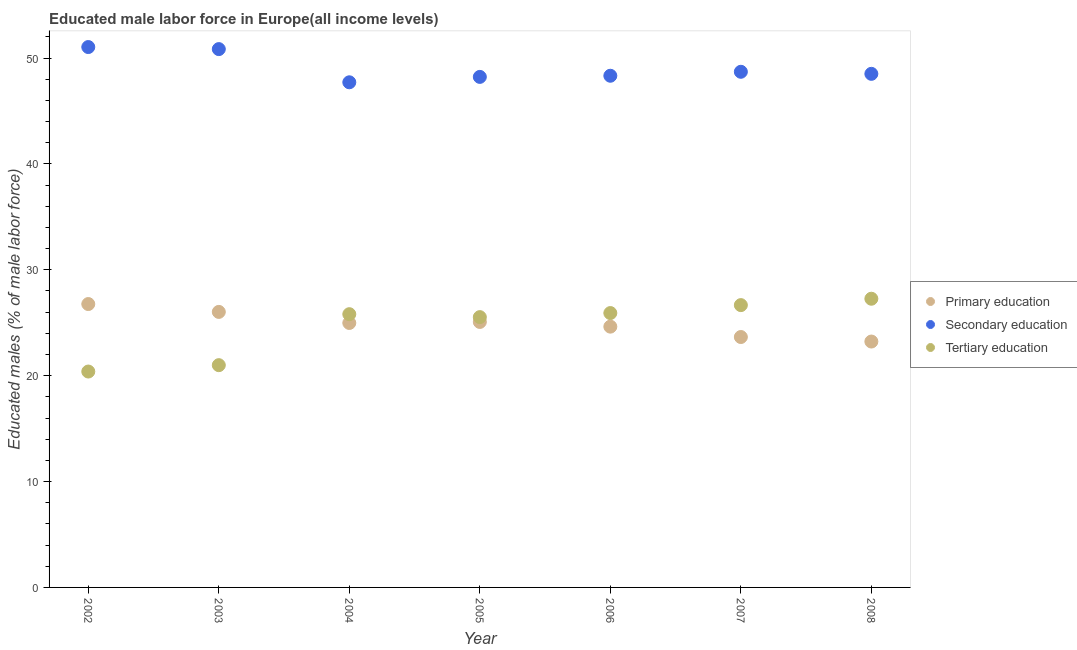Is the number of dotlines equal to the number of legend labels?
Keep it short and to the point. Yes. What is the percentage of male labor force who received tertiary education in 2005?
Offer a terse response. 25.53. Across all years, what is the maximum percentage of male labor force who received tertiary education?
Offer a terse response. 27.27. Across all years, what is the minimum percentage of male labor force who received primary education?
Ensure brevity in your answer.  23.22. In which year was the percentage of male labor force who received tertiary education maximum?
Offer a very short reply. 2008. In which year was the percentage of male labor force who received tertiary education minimum?
Your answer should be compact. 2002. What is the total percentage of male labor force who received secondary education in the graph?
Provide a succinct answer. 343.35. What is the difference between the percentage of male labor force who received primary education in 2003 and that in 2008?
Offer a very short reply. 2.8. What is the difference between the percentage of male labor force who received tertiary education in 2007 and the percentage of male labor force who received secondary education in 2005?
Your response must be concise. -21.55. What is the average percentage of male labor force who received secondary education per year?
Ensure brevity in your answer.  49.05. In the year 2008, what is the difference between the percentage of male labor force who received tertiary education and percentage of male labor force who received primary education?
Offer a very short reply. 4.04. What is the ratio of the percentage of male labor force who received secondary education in 2003 to that in 2007?
Provide a succinct answer. 1.04. What is the difference between the highest and the second highest percentage of male labor force who received tertiary education?
Your answer should be compact. 0.6. What is the difference between the highest and the lowest percentage of male labor force who received tertiary education?
Provide a succinct answer. 6.88. In how many years, is the percentage of male labor force who received primary education greater than the average percentage of male labor force who received primary education taken over all years?
Make the answer very short. 4. Is the sum of the percentage of male labor force who received secondary education in 2002 and 2008 greater than the maximum percentage of male labor force who received tertiary education across all years?
Provide a short and direct response. Yes. Is it the case that in every year, the sum of the percentage of male labor force who received primary education and percentage of male labor force who received secondary education is greater than the percentage of male labor force who received tertiary education?
Your answer should be compact. Yes. Is the percentage of male labor force who received tertiary education strictly greater than the percentage of male labor force who received primary education over the years?
Provide a short and direct response. No. How many years are there in the graph?
Provide a succinct answer. 7. Are the values on the major ticks of Y-axis written in scientific E-notation?
Offer a terse response. No. Where does the legend appear in the graph?
Your answer should be very brief. Center right. What is the title of the graph?
Offer a very short reply. Educated male labor force in Europe(all income levels). What is the label or title of the Y-axis?
Provide a short and direct response. Educated males (% of male labor force). What is the Educated males (% of male labor force) in Primary education in 2002?
Provide a short and direct response. 26.77. What is the Educated males (% of male labor force) of Secondary education in 2002?
Your response must be concise. 51.04. What is the Educated males (% of male labor force) of Tertiary education in 2002?
Ensure brevity in your answer.  20.39. What is the Educated males (% of male labor force) of Primary education in 2003?
Ensure brevity in your answer.  26.02. What is the Educated males (% of male labor force) in Secondary education in 2003?
Offer a terse response. 50.84. What is the Educated males (% of male labor force) of Tertiary education in 2003?
Ensure brevity in your answer.  20.99. What is the Educated males (% of male labor force) of Primary education in 2004?
Keep it short and to the point. 24.98. What is the Educated males (% of male labor force) in Secondary education in 2004?
Offer a very short reply. 47.71. What is the Educated males (% of male labor force) in Tertiary education in 2004?
Offer a terse response. 25.81. What is the Educated males (% of male labor force) in Primary education in 2005?
Your answer should be very brief. 25.07. What is the Educated males (% of male labor force) in Secondary education in 2005?
Ensure brevity in your answer.  48.22. What is the Educated males (% of male labor force) of Tertiary education in 2005?
Offer a very short reply. 25.53. What is the Educated males (% of male labor force) of Primary education in 2006?
Provide a short and direct response. 24.63. What is the Educated males (% of male labor force) of Secondary education in 2006?
Offer a very short reply. 48.33. What is the Educated males (% of male labor force) of Tertiary education in 2006?
Your response must be concise. 25.91. What is the Educated males (% of male labor force) of Primary education in 2007?
Provide a short and direct response. 23.65. What is the Educated males (% of male labor force) in Secondary education in 2007?
Offer a very short reply. 48.7. What is the Educated males (% of male labor force) of Tertiary education in 2007?
Keep it short and to the point. 26.66. What is the Educated males (% of male labor force) of Primary education in 2008?
Give a very brief answer. 23.22. What is the Educated males (% of male labor force) of Secondary education in 2008?
Provide a succinct answer. 48.51. What is the Educated males (% of male labor force) of Tertiary education in 2008?
Ensure brevity in your answer.  27.27. Across all years, what is the maximum Educated males (% of male labor force) in Primary education?
Give a very brief answer. 26.77. Across all years, what is the maximum Educated males (% of male labor force) of Secondary education?
Provide a short and direct response. 51.04. Across all years, what is the maximum Educated males (% of male labor force) of Tertiary education?
Offer a very short reply. 27.27. Across all years, what is the minimum Educated males (% of male labor force) of Primary education?
Offer a very short reply. 23.22. Across all years, what is the minimum Educated males (% of male labor force) in Secondary education?
Provide a succinct answer. 47.71. Across all years, what is the minimum Educated males (% of male labor force) in Tertiary education?
Offer a terse response. 20.39. What is the total Educated males (% of male labor force) of Primary education in the graph?
Ensure brevity in your answer.  174.34. What is the total Educated males (% of male labor force) of Secondary education in the graph?
Your answer should be compact. 343.35. What is the total Educated males (% of male labor force) in Tertiary education in the graph?
Offer a terse response. 172.57. What is the difference between the Educated males (% of male labor force) in Primary education in 2002 and that in 2003?
Your response must be concise. 0.74. What is the difference between the Educated males (% of male labor force) of Secondary education in 2002 and that in 2003?
Keep it short and to the point. 0.19. What is the difference between the Educated males (% of male labor force) of Tertiary education in 2002 and that in 2003?
Give a very brief answer. -0.6. What is the difference between the Educated males (% of male labor force) of Primary education in 2002 and that in 2004?
Give a very brief answer. 1.79. What is the difference between the Educated males (% of male labor force) in Secondary education in 2002 and that in 2004?
Your response must be concise. 3.33. What is the difference between the Educated males (% of male labor force) in Tertiary education in 2002 and that in 2004?
Ensure brevity in your answer.  -5.42. What is the difference between the Educated males (% of male labor force) of Primary education in 2002 and that in 2005?
Give a very brief answer. 1.69. What is the difference between the Educated males (% of male labor force) of Secondary education in 2002 and that in 2005?
Provide a short and direct response. 2.82. What is the difference between the Educated males (% of male labor force) of Tertiary education in 2002 and that in 2005?
Ensure brevity in your answer.  -5.14. What is the difference between the Educated males (% of male labor force) in Primary education in 2002 and that in 2006?
Your response must be concise. 2.14. What is the difference between the Educated males (% of male labor force) of Secondary education in 2002 and that in 2006?
Provide a short and direct response. 2.71. What is the difference between the Educated males (% of male labor force) of Tertiary education in 2002 and that in 2006?
Your answer should be very brief. -5.52. What is the difference between the Educated males (% of male labor force) of Primary education in 2002 and that in 2007?
Offer a terse response. 3.11. What is the difference between the Educated males (% of male labor force) of Secondary education in 2002 and that in 2007?
Provide a succinct answer. 2.34. What is the difference between the Educated males (% of male labor force) in Tertiary education in 2002 and that in 2007?
Provide a short and direct response. -6.27. What is the difference between the Educated males (% of male labor force) in Primary education in 2002 and that in 2008?
Provide a short and direct response. 3.54. What is the difference between the Educated males (% of male labor force) in Secondary education in 2002 and that in 2008?
Offer a terse response. 2.53. What is the difference between the Educated males (% of male labor force) of Tertiary education in 2002 and that in 2008?
Your answer should be compact. -6.88. What is the difference between the Educated males (% of male labor force) of Primary education in 2003 and that in 2004?
Offer a terse response. 1.04. What is the difference between the Educated males (% of male labor force) in Secondary education in 2003 and that in 2004?
Your answer should be very brief. 3.13. What is the difference between the Educated males (% of male labor force) in Tertiary education in 2003 and that in 2004?
Ensure brevity in your answer.  -4.81. What is the difference between the Educated males (% of male labor force) in Primary education in 2003 and that in 2005?
Provide a succinct answer. 0.95. What is the difference between the Educated males (% of male labor force) of Secondary education in 2003 and that in 2005?
Provide a succinct answer. 2.62. What is the difference between the Educated males (% of male labor force) of Tertiary education in 2003 and that in 2005?
Provide a succinct answer. -4.54. What is the difference between the Educated males (% of male labor force) in Primary education in 2003 and that in 2006?
Provide a succinct answer. 1.39. What is the difference between the Educated males (% of male labor force) of Secondary education in 2003 and that in 2006?
Provide a succinct answer. 2.52. What is the difference between the Educated males (% of male labor force) of Tertiary education in 2003 and that in 2006?
Ensure brevity in your answer.  -4.92. What is the difference between the Educated males (% of male labor force) of Primary education in 2003 and that in 2007?
Ensure brevity in your answer.  2.37. What is the difference between the Educated males (% of male labor force) of Secondary education in 2003 and that in 2007?
Provide a short and direct response. 2.14. What is the difference between the Educated males (% of male labor force) of Tertiary education in 2003 and that in 2007?
Your answer should be compact. -5.67. What is the difference between the Educated males (% of male labor force) of Primary education in 2003 and that in 2008?
Give a very brief answer. 2.8. What is the difference between the Educated males (% of male labor force) in Secondary education in 2003 and that in 2008?
Provide a short and direct response. 2.34. What is the difference between the Educated males (% of male labor force) of Tertiary education in 2003 and that in 2008?
Your answer should be compact. -6.27. What is the difference between the Educated males (% of male labor force) in Primary education in 2004 and that in 2005?
Make the answer very short. -0.1. What is the difference between the Educated males (% of male labor force) in Secondary education in 2004 and that in 2005?
Provide a short and direct response. -0.51. What is the difference between the Educated males (% of male labor force) in Tertiary education in 2004 and that in 2005?
Make the answer very short. 0.28. What is the difference between the Educated males (% of male labor force) in Primary education in 2004 and that in 2006?
Make the answer very short. 0.35. What is the difference between the Educated males (% of male labor force) in Secondary education in 2004 and that in 2006?
Provide a short and direct response. -0.62. What is the difference between the Educated males (% of male labor force) in Tertiary education in 2004 and that in 2006?
Ensure brevity in your answer.  -0.11. What is the difference between the Educated males (% of male labor force) in Primary education in 2004 and that in 2007?
Give a very brief answer. 1.33. What is the difference between the Educated males (% of male labor force) in Secondary education in 2004 and that in 2007?
Keep it short and to the point. -0.99. What is the difference between the Educated males (% of male labor force) of Tertiary education in 2004 and that in 2007?
Your answer should be very brief. -0.86. What is the difference between the Educated males (% of male labor force) of Primary education in 2004 and that in 2008?
Keep it short and to the point. 1.75. What is the difference between the Educated males (% of male labor force) of Secondary education in 2004 and that in 2008?
Offer a terse response. -0.8. What is the difference between the Educated males (% of male labor force) in Tertiary education in 2004 and that in 2008?
Your answer should be compact. -1.46. What is the difference between the Educated males (% of male labor force) of Primary education in 2005 and that in 2006?
Provide a succinct answer. 0.45. What is the difference between the Educated males (% of male labor force) of Secondary education in 2005 and that in 2006?
Offer a terse response. -0.11. What is the difference between the Educated males (% of male labor force) in Tertiary education in 2005 and that in 2006?
Your response must be concise. -0.38. What is the difference between the Educated males (% of male labor force) in Primary education in 2005 and that in 2007?
Provide a succinct answer. 1.42. What is the difference between the Educated males (% of male labor force) in Secondary education in 2005 and that in 2007?
Keep it short and to the point. -0.48. What is the difference between the Educated males (% of male labor force) in Tertiary education in 2005 and that in 2007?
Your answer should be very brief. -1.13. What is the difference between the Educated males (% of male labor force) in Primary education in 2005 and that in 2008?
Make the answer very short. 1.85. What is the difference between the Educated males (% of male labor force) in Secondary education in 2005 and that in 2008?
Make the answer very short. -0.29. What is the difference between the Educated males (% of male labor force) of Tertiary education in 2005 and that in 2008?
Offer a very short reply. -1.74. What is the difference between the Educated males (% of male labor force) in Primary education in 2006 and that in 2007?
Make the answer very short. 0.98. What is the difference between the Educated males (% of male labor force) in Secondary education in 2006 and that in 2007?
Your response must be concise. -0.37. What is the difference between the Educated males (% of male labor force) in Tertiary education in 2006 and that in 2007?
Provide a short and direct response. -0.75. What is the difference between the Educated males (% of male labor force) in Primary education in 2006 and that in 2008?
Provide a succinct answer. 1.41. What is the difference between the Educated males (% of male labor force) of Secondary education in 2006 and that in 2008?
Offer a very short reply. -0.18. What is the difference between the Educated males (% of male labor force) of Tertiary education in 2006 and that in 2008?
Give a very brief answer. -1.35. What is the difference between the Educated males (% of male labor force) in Primary education in 2007 and that in 2008?
Make the answer very short. 0.43. What is the difference between the Educated males (% of male labor force) of Secondary education in 2007 and that in 2008?
Ensure brevity in your answer.  0.19. What is the difference between the Educated males (% of male labor force) of Tertiary education in 2007 and that in 2008?
Offer a very short reply. -0.6. What is the difference between the Educated males (% of male labor force) in Primary education in 2002 and the Educated males (% of male labor force) in Secondary education in 2003?
Your answer should be compact. -24.08. What is the difference between the Educated males (% of male labor force) of Primary education in 2002 and the Educated males (% of male labor force) of Tertiary education in 2003?
Keep it short and to the point. 5.77. What is the difference between the Educated males (% of male labor force) of Secondary education in 2002 and the Educated males (% of male labor force) of Tertiary education in 2003?
Your answer should be very brief. 30.05. What is the difference between the Educated males (% of male labor force) of Primary education in 2002 and the Educated males (% of male labor force) of Secondary education in 2004?
Keep it short and to the point. -20.94. What is the difference between the Educated males (% of male labor force) in Primary education in 2002 and the Educated males (% of male labor force) in Tertiary education in 2004?
Offer a very short reply. 0.96. What is the difference between the Educated males (% of male labor force) of Secondary education in 2002 and the Educated males (% of male labor force) of Tertiary education in 2004?
Give a very brief answer. 25.23. What is the difference between the Educated males (% of male labor force) in Primary education in 2002 and the Educated males (% of male labor force) in Secondary education in 2005?
Ensure brevity in your answer.  -21.45. What is the difference between the Educated males (% of male labor force) of Primary education in 2002 and the Educated males (% of male labor force) of Tertiary education in 2005?
Keep it short and to the point. 1.24. What is the difference between the Educated males (% of male labor force) in Secondary education in 2002 and the Educated males (% of male labor force) in Tertiary education in 2005?
Keep it short and to the point. 25.51. What is the difference between the Educated males (% of male labor force) of Primary education in 2002 and the Educated males (% of male labor force) of Secondary education in 2006?
Keep it short and to the point. -21.56. What is the difference between the Educated males (% of male labor force) in Primary education in 2002 and the Educated males (% of male labor force) in Tertiary education in 2006?
Provide a short and direct response. 0.85. What is the difference between the Educated males (% of male labor force) in Secondary education in 2002 and the Educated males (% of male labor force) in Tertiary education in 2006?
Your answer should be very brief. 25.12. What is the difference between the Educated males (% of male labor force) in Primary education in 2002 and the Educated males (% of male labor force) in Secondary education in 2007?
Provide a succinct answer. -21.94. What is the difference between the Educated males (% of male labor force) in Primary education in 2002 and the Educated males (% of male labor force) in Tertiary education in 2007?
Give a very brief answer. 0.1. What is the difference between the Educated males (% of male labor force) of Secondary education in 2002 and the Educated males (% of male labor force) of Tertiary education in 2007?
Offer a terse response. 24.37. What is the difference between the Educated males (% of male labor force) of Primary education in 2002 and the Educated males (% of male labor force) of Secondary education in 2008?
Offer a terse response. -21.74. What is the difference between the Educated males (% of male labor force) in Primary education in 2002 and the Educated males (% of male labor force) in Tertiary education in 2008?
Your answer should be compact. -0.5. What is the difference between the Educated males (% of male labor force) of Secondary education in 2002 and the Educated males (% of male labor force) of Tertiary education in 2008?
Give a very brief answer. 23.77. What is the difference between the Educated males (% of male labor force) in Primary education in 2003 and the Educated males (% of male labor force) in Secondary education in 2004?
Keep it short and to the point. -21.69. What is the difference between the Educated males (% of male labor force) in Primary education in 2003 and the Educated males (% of male labor force) in Tertiary education in 2004?
Offer a very short reply. 0.21. What is the difference between the Educated males (% of male labor force) of Secondary education in 2003 and the Educated males (% of male labor force) of Tertiary education in 2004?
Offer a terse response. 25.04. What is the difference between the Educated males (% of male labor force) in Primary education in 2003 and the Educated males (% of male labor force) in Secondary education in 2005?
Your response must be concise. -22.2. What is the difference between the Educated males (% of male labor force) of Primary education in 2003 and the Educated males (% of male labor force) of Tertiary education in 2005?
Keep it short and to the point. 0.49. What is the difference between the Educated males (% of male labor force) of Secondary education in 2003 and the Educated males (% of male labor force) of Tertiary education in 2005?
Provide a short and direct response. 25.31. What is the difference between the Educated males (% of male labor force) in Primary education in 2003 and the Educated males (% of male labor force) in Secondary education in 2006?
Your answer should be very brief. -22.3. What is the difference between the Educated males (% of male labor force) of Primary education in 2003 and the Educated males (% of male labor force) of Tertiary education in 2006?
Offer a terse response. 0.11. What is the difference between the Educated males (% of male labor force) in Secondary education in 2003 and the Educated males (% of male labor force) in Tertiary education in 2006?
Offer a terse response. 24.93. What is the difference between the Educated males (% of male labor force) in Primary education in 2003 and the Educated males (% of male labor force) in Secondary education in 2007?
Your answer should be very brief. -22.68. What is the difference between the Educated males (% of male labor force) of Primary education in 2003 and the Educated males (% of male labor force) of Tertiary education in 2007?
Keep it short and to the point. -0.64. What is the difference between the Educated males (% of male labor force) of Secondary education in 2003 and the Educated males (% of male labor force) of Tertiary education in 2007?
Provide a succinct answer. 24.18. What is the difference between the Educated males (% of male labor force) of Primary education in 2003 and the Educated males (% of male labor force) of Secondary education in 2008?
Offer a terse response. -22.48. What is the difference between the Educated males (% of male labor force) of Primary education in 2003 and the Educated males (% of male labor force) of Tertiary education in 2008?
Keep it short and to the point. -1.24. What is the difference between the Educated males (% of male labor force) of Secondary education in 2003 and the Educated males (% of male labor force) of Tertiary education in 2008?
Give a very brief answer. 23.58. What is the difference between the Educated males (% of male labor force) of Primary education in 2004 and the Educated males (% of male labor force) of Secondary education in 2005?
Ensure brevity in your answer.  -23.24. What is the difference between the Educated males (% of male labor force) in Primary education in 2004 and the Educated males (% of male labor force) in Tertiary education in 2005?
Your response must be concise. -0.55. What is the difference between the Educated males (% of male labor force) in Secondary education in 2004 and the Educated males (% of male labor force) in Tertiary education in 2005?
Make the answer very short. 22.18. What is the difference between the Educated males (% of male labor force) of Primary education in 2004 and the Educated males (% of male labor force) of Secondary education in 2006?
Your answer should be very brief. -23.35. What is the difference between the Educated males (% of male labor force) of Primary education in 2004 and the Educated males (% of male labor force) of Tertiary education in 2006?
Your response must be concise. -0.94. What is the difference between the Educated males (% of male labor force) of Secondary education in 2004 and the Educated males (% of male labor force) of Tertiary education in 2006?
Your answer should be very brief. 21.8. What is the difference between the Educated males (% of male labor force) in Primary education in 2004 and the Educated males (% of male labor force) in Secondary education in 2007?
Your response must be concise. -23.72. What is the difference between the Educated males (% of male labor force) in Primary education in 2004 and the Educated males (% of male labor force) in Tertiary education in 2007?
Make the answer very short. -1.69. What is the difference between the Educated males (% of male labor force) of Secondary education in 2004 and the Educated males (% of male labor force) of Tertiary education in 2007?
Offer a terse response. 21.05. What is the difference between the Educated males (% of male labor force) of Primary education in 2004 and the Educated males (% of male labor force) of Secondary education in 2008?
Your answer should be compact. -23.53. What is the difference between the Educated males (% of male labor force) in Primary education in 2004 and the Educated males (% of male labor force) in Tertiary education in 2008?
Give a very brief answer. -2.29. What is the difference between the Educated males (% of male labor force) in Secondary education in 2004 and the Educated males (% of male labor force) in Tertiary education in 2008?
Ensure brevity in your answer.  20.44. What is the difference between the Educated males (% of male labor force) of Primary education in 2005 and the Educated males (% of male labor force) of Secondary education in 2006?
Ensure brevity in your answer.  -23.25. What is the difference between the Educated males (% of male labor force) in Primary education in 2005 and the Educated males (% of male labor force) in Tertiary education in 2006?
Your answer should be very brief. -0.84. What is the difference between the Educated males (% of male labor force) of Secondary education in 2005 and the Educated males (% of male labor force) of Tertiary education in 2006?
Provide a succinct answer. 22.31. What is the difference between the Educated males (% of male labor force) of Primary education in 2005 and the Educated males (% of male labor force) of Secondary education in 2007?
Your answer should be very brief. -23.63. What is the difference between the Educated males (% of male labor force) of Primary education in 2005 and the Educated males (% of male labor force) of Tertiary education in 2007?
Keep it short and to the point. -1.59. What is the difference between the Educated males (% of male labor force) in Secondary education in 2005 and the Educated males (% of male labor force) in Tertiary education in 2007?
Provide a short and direct response. 21.55. What is the difference between the Educated males (% of male labor force) in Primary education in 2005 and the Educated males (% of male labor force) in Secondary education in 2008?
Your response must be concise. -23.43. What is the difference between the Educated males (% of male labor force) of Primary education in 2005 and the Educated males (% of male labor force) of Tertiary education in 2008?
Your response must be concise. -2.19. What is the difference between the Educated males (% of male labor force) in Secondary education in 2005 and the Educated males (% of male labor force) in Tertiary education in 2008?
Keep it short and to the point. 20.95. What is the difference between the Educated males (% of male labor force) in Primary education in 2006 and the Educated males (% of male labor force) in Secondary education in 2007?
Give a very brief answer. -24.07. What is the difference between the Educated males (% of male labor force) of Primary education in 2006 and the Educated males (% of male labor force) of Tertiary education in 2007?
Offer a very short reply. -2.03. What is the difference between the Educated males (% of male labor force) in Secondary education in 2006 and the Educated males (% of male labor force) in Tertiary education in 2007?
Give a very brief answer. 21.66. What is the difference between the Educated males (% of male labor force) in Primary education in 2006 and the Educated males (% of male labor force) in Secondary education in 2008?
Give a very brief answer. -23.88. What is the difference between the Educated males (% of male labor force) of Primary education in 2006 and the Educated males (% of male labor force) of Tertiary education in 2008?
Your answer should be compact. -2.64. What is the difference between the Educated males (% of male labor force) of Secondary education in 2006 and the Educated males (% of male labor force) of Tertiary education in 2008?
Make the answer very short. 21.06. What is the difference between the Educated males (% of male labor force) in Primary education in 2007 and the Educated males (% of male labor force) in Secondary education in 2008?
Ensure brevity in your answer.  -24.86. What is the difference between the Educated males (% of male labor force) in Primary education in 2007 and the Educated males (% of male labor force) in Tertiary education in 2008?
Ensure brevity in your answer.  -3.62. What is the difference between the Educated males (% of male labor force) in Secondary education in 2007 and the Educated males (% of male labor force) in Tertiary education in 2008?
Your answer should be compact. 21.43. What is the average Educated males (% of male labor force) of Primary education per year?
Your answer should be compact. 24.91. What is the average Educated males (% of male labor force) of Secondary education per year?
Your answer should be very brief. 49.05. What is the average Educated males (% of male labor force) in Tertiary education per year?
Offer a very short reply. 24.65. In the year 2002, what is the difference between the Educated males (% of male labor force) of Primary education and Educated males (% of male labor force) of Secondary education?
Provide a short and direct response. -24.27. In the year 2002, what is the difference between the Educated males (% of male labor force) in Primary education and Educated males (% of male labor force) in Tertiary education?
Offer a very short reply. 6.37. In the year 2002, what is the difference between the Educated males (% of male labor force) in Secondary education and Educated males (% of male labor force) in Tertiary education?
Your answer should be compact. 30.65. In the year 2003, what is the difference between the Educated males (% of male labor force) in Primary education and Educated males (% of male labor force) in Secondary education?
Ensure brevity in your answer.  -24.82. In the year 2003, what is the difference between the Educated males (% of male labor force) in Primary education and Educated males (% of male labor force) in Tertiary education?
Your response must be concise. 5.03. In the year 2003, what is the difference between the Educated males (% of male labor force) of Secondary education and Educated males (% of male labor force) of Tertiary education?
Ensure brevity in your answer.  29.85. In the year 2004, what is the difference between the Educated males (% of male labor force) in Primary education and Educated males (% of male labor force) in Secondary education?
Make the answer very short. -22.73. In the year 2004, what is the difference between the Educated males (% of male labor force) in Primary education and Educated males (% of male labor force) in Tertiary education?
Give a very brief answer. -0.83. In the year 2004, what is the difference between the Educated males (% of male labor force) of Secondary education and Educated males (% of male labor force) of Tertiary education?
Provide a short and direct response. 21.9. In the year 2005, what is the difference between the Educated males (% of male labor force) in Primary education and Educated males (% of male labor force) in Secondary education?
Provide a succinct answer. -23.14. In the year 2005, what is the difference between the Educated males (% of male labor force) of Primary education and Educated males (% of male labor force) of Tertiary education?
Provide a succinct answer. -0.45. In the year 2005, what is the difference between the Educated males (% of male labor force) in Secondary education and Educated males (% of male labor force) in Tertiary education?
Your answer should be very brief. 22.69. In the year 2006, what is the difference between the Educated males (% of male labor force) in Primary education and Educated males (% of male labor force) in Secondary education?
Give a very brief answer. -23.7. In the year 2006, what is the difference between the Educated males (% of male labor force) in Primary education and Educated males (% of male labor force) in Tertiary education?
Your answer should be very brief. -1.28. In the year 2006, what is the difference between the Educated males (% of male labor force) of Secondary education and Educated males (% of male labor force) of Tertiary education?
Your answer should be compact. 22.41. In the year 2007, what is the difference between the Educated males (% of male labor force) in Primary education and Educated males (% of male labor force) in Secondary education?
Provide a succinct answer. -25.05. In the year 2007, what is the difference between the Educated males (% of male labor force) in Primary education and Educated males (% of male labor force) in Tertiary education?
Provide a succinct answer. -3.01. In the year 2007, what is the difference between the Educated males (% of male labor force) in Secondary education and Educated males (% of male labor force) in Tertiary education?
Keep it short and to the point. 22.04. In the year 2008, what is the difference between the Educated males (% of male labor force) in Primary education and Educated males (% of male labor force) in Secondary education?
Offer a terse response. -25.28. In the year 2008, what is the difference between the Educated males (% of male labor force) of Primary education and Educated males (% of male labor force) of Tertiary education?
Your answer should be very brief. -4.04. In the year 2008, what is the difference between the Educated males (% of male labor force) of Secondary education and Educated males (% of male labor force) of Tertiary education?
Offer a terse response. 21.24. What is the ratio of the Educated males (% of male labor force) in Primary education in 2002 to that in 2003?
Offer a very short reply. 1.03. What is the ratio of the Educated males (% of male labor force) of Tertiary education in 2002 to that in 2003?
Give a very brief answer. 0.97. What is the ratio of the Educated males (% of male labor force) in Primary education in 2002 to that in 2004?
Your response must be concise. 1.07. What is the ratio of the Educated males (% of male labor force) in Secondary education in 2002 to that in 2004?
Give a very brief answer. 1.07. What is the ratio of the Educated males (% of male labor force) in Tertiary education in 2002 to that in 2004?
Your response must be concise. 0.79. What is the ratio of the Educated males (% of male labor force) in Primary education in 2002 to that in 2005?
Ensure brevity in your answer.  1.07. What is the ratio of the Educated males (% of male labor force) in Secondary education in 2002 to that in 2005?
Provide a short and direct response. 1.06. What is the ratio of the Educated males (% of male labor force) in Tertiary education in 2002 to that in 2005?
Provide a short and direct response. 0.8. What is the ratio of the Educated males (% of male labor force) of Primary education in 2002 to that in 2006?
Your answer should be compact. 1.09. What is the ratio of the Educated males (% of male labor force) of Secondary education in 2002 to that in 2006?
Make the answer very short. 1.06. What is the ratio of the Educated males (% of male labor force) in Tertiary education in 2002 to that in 2006?
Give a very brief answer. 0.79. What is the ratio of the Educated males (% of male labor force) of Primary education in 2002 to that in 2007?
Your response must be concise. 1.13. What is the ratio of the Educated males (% of male labor force) of Secondary education in 2002 to that in 2007?
Provide a succinct answer. 1.05. What is the ratio of the Educated males (% of male labor force) in Tertiary education in 2002 to that in 2007?
Your answer should be compact. 0.76. What is the ratio of the Educated males (% of male labor force) in Primary education in 2002 to that in 2008?
Ensure brevity in your answer.  1.15. What is the ratio of the Educated males (% of male labor force) in Secondary education in 2002 to that in 2008?
Keep it short and to the point. 1.05. What is the ratio of the Educated males (% of male labor force) in Tertiary education in 2002 to that in 2008?
Your answer should be compact. 0.75. What is the ratio of the Educated males (% of male labor force) in Primary education in 2003 to that in 2004?
Ensure brevity in your answer.  1.04. What is the ratio of the Educated males (% of male labor force) of Secondary education in 2003 to that in 2004?
Provide a succinct answer. 1.07. What is the ratio of the Educated males (% of male labor force) of Tertiary education in 2003 to that in 2004?
Give a very brief answer. 0.81. What is the ratio of the Educated males (% of male labor force) in Primary education in 2003 to that in 2005?
Offer a terse response. 1.04. What is the ratio of the Educated males (% of male labor force) of Secondary education in 2003 to that in 2005?
Offer a terse response. 1.05. What is the ratio of the Educated males (% of male labor force) of Tertiary education in 2003 to that in 2005?
Provide a succinct answer. 0.82. What is the ratio of the Educated males (% of male labor force) of Primary education in 2003 to that in 2006?
Your response must be concise. 1.06. What is the ratio of the Educated males (% of male labor force) in Secondary education in 2003 to that in 2006?
Offer a very short reply. 1.05. What is the ratio of the Educated males (% of male labor force) in Tertiary education in 2003 to that in 2006?
Give a very brief answer. 0.81. What is the ratio of the Educated males (% of male labor force) in Primary education in 2003 to that in 2007?
Offer a very short reply. 1.1. What is the ratio of the Educated males (% of male labor force) of Secondary education in 2003 to that in 2007?
Offer a very short reply. 1.04. What is the ratio of the Educated males (% of male labor force) in Tertiary education in 2003 to that in 2007?
Make the answer very short. 0.79. What is the ratio of the Educated males (% of male labor force) of Primary education in 2003 to that in 2008?
Provide a succinct answer. 1.12. What is the ratio of the Educated males (% of male labor force) of Secondary education in 2003 to that in 2008?
Make the answer very short. 1.05. What is the ratio of the Educated males (% of male labor force) of Tertiary education in 2003 to that in 2008?
Provide a succinct answer. 0.77. What is the ratio of the Educated males (% of male labor force) of Primary education in 2004 to that in 2005?
Keep it short and to the point. 1. What is the ratio of the Educated males (% of male labor force) in Tertiary education in 2004 to that in 2005?
Give a very brief answer. 1.01. What is the ratio of the Educated males (% of male labor force) in Primary education in 2004 to that in 2006?
Ensure brevity in your answer.  1.01. What is the ratio of the Educated males (% of male labor force) in Secondary education in 2004 to that in 2006?
Make the answer very short. 0.99. What is the ratio of the Educated males (% of male labor force) in Primary education in 2004 to that in 2007?
Make the answer very short. 1.06. What is the ratio of the Educated males (% of male labor force) of Secondary education in 2004 to that in 2007?
Ensure brevity in your answer.  0.98. What is the ratio of the Educated males (% of male labor force) in Tertiary education in 2004 to that in 2007?
Your answer should be very brief. 0.97. What is the ratio of the Educated males (% of male labor force) of Primary education in 2004 to that in 2008?
Provide a succinct answer. 1.08. What is the ratio of the Educated males (% of male labor force) in Secondary education in 2004 to that in 2008?
Provide a succinct answer. 0.98. What is the ratio of the Educated males (% of male labor force) in Tertiary education in 2004 to that in 2008?
Offer a very short reply. 0.95. What is the ratio of the Educated males (% of male labor force) in Primary education in 2005 to that in 2006?
Keep it short and to the point. 1.02. What is the ratio of the Educated males (% of male labor force) of Secondary education in 2005 to that in 2006?
Your response must be concise. 1. What is the ratio of the Educated males (% of male labor force) of Tertiary education in 2005 to that in 2006?
Provide a short and direct response. 0.99. What is the ratio of the Educated males (% of male labor force) of Primary education in 2005 to that in 2007?
Offer a terse response. 1.06. What is the ratio of the Educated males (% of male labor force) of Tertiary education in 2005 to that in 2007?
Ensure brevity in your answer.  0.96. What is the ratio of the Educated males (% of male labor force) of Primary education in 2005 to that in 2008?
Your answer should be compact. 1.08. What is the ratio of the Educated males (% of male labor force) of Tertiary education in 2005 to that in 2008?
Provide a short and direct response. 0.94. What is the ratio of the Educated males (% of male labor force) in Primary education in 2006 to that in 2007?
Your response must be concise. 1.04. What is the ratio of the Educated males (% of male labor force) of Secondary education in 2006 to that in 2007?
Your answer should be very brief. 0.99. What is the ratio of the Educated males (% of male labor force) of Tertiary education in 2006 to that in 2007?
Your answer should be compact. 0.97. What is the ratio of the Educated males (% of male labor force) of Primary education in 2006 to that in 2008?
Your answer should be compact. 1.06. What is the ratio of the Educated males (% of male labor force) in Secondary education in 2006 to that in 2008?
Your answer should be very brief. 1. What is the ratio of the Educated males (% of male labor force) in Tertiary education in 2006 to that in 2008?
Offer a very short reply. 0.95. What is the ratio of the Educated males (% of male labor force) of Primary education in 2007 to that in 2008?
Offer a terse response. 1.02. What is the ratio of the Educated males (% of male labor force) of Tertiary education in 2007 to that in 2008?
Make the answer very short. 0.98. What is the difference between the highest and the second highest Educated males (% of male labor force) of Primary education?
Offer a very short reply. 0.74. What is the difference between the highest and the second highest Educated males (% of male labor force) in Secondary education?
Make the answer very short. 0.19. What is the difference between the highest and the second highest Educated males (% of male labor force) in Tertiary education?
Your response must be concise. 0.6. What is the difference between the highest and the lowest Educated males (% of male labor force) of Primary education?
Make the answer very short. 3.54. What is the difference between the highest and the lowest Educated males (% of male labor force) of Secondary education?
Provide a short and direct response. 3.33. What is the difference between the highest and the lowest Educated males (% of male labor force) of Tertiary education?
Give a very brief answer. 6.88. 